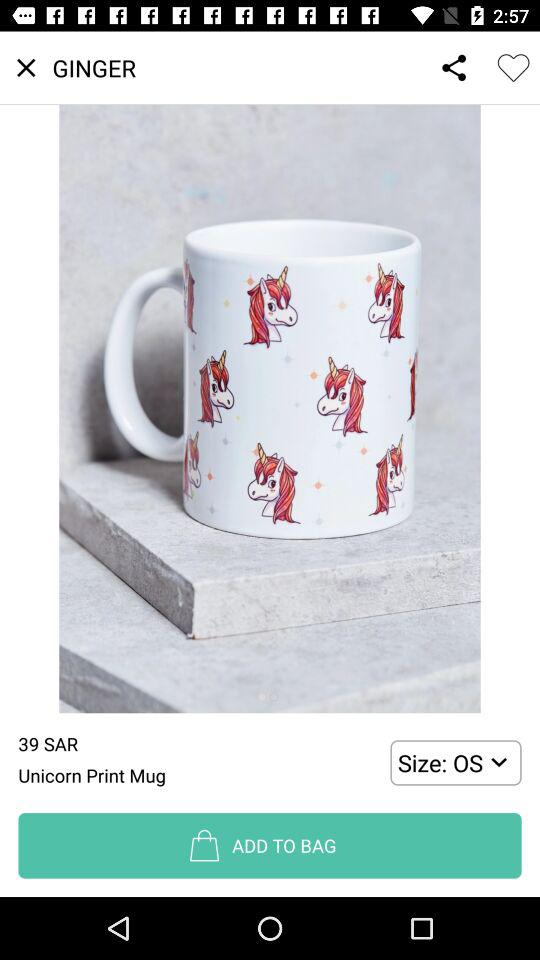What is the price of the item?
Answer the question using a single word or phrase. 39 SAR 